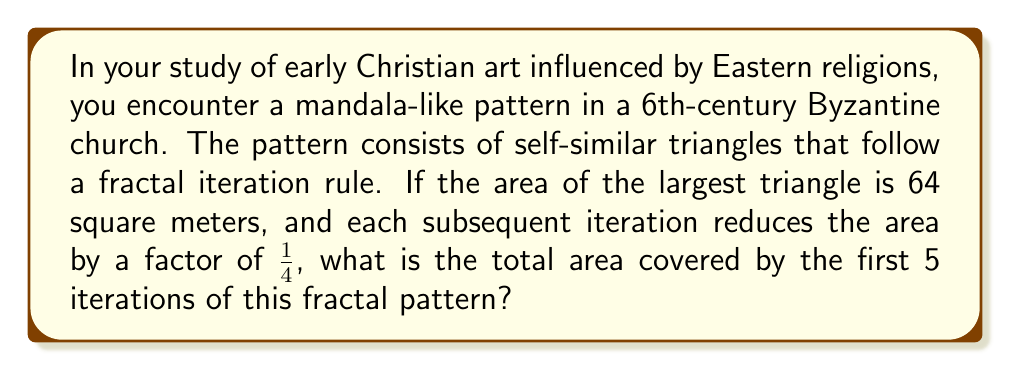Help me with this question. Let's approach this step-by-step:

1) First, let's define our series of areas:
   $A_1 = 64$ m² (given)
   $A_n = \frac{1}{4} A_{n-1}$ for $n > 1$

2) We can write out the first 5 terms:
   $A_1 = 64$ m²
   $A_2 = 64 \cdot \frac{1}{4} = 16$ m²
   $A_3 = 16 \cdot \frac{1}{4} = 4$ m²
   $A_4 = 4 \cdot \frac{1}{4} = 1$ m²
   $A_5 = 1 \cdot \frac{1}{4} = 0.25$ m²

3) The total area is the sum of these 5 terms:
   $A_{total} = A_1 + A_2 + A_3 + A_4 + A_5$

4) We can also express this as a geometric series:
   $A_{total} = 64 + 64(\frac{1}{4}) + 64(\frac{1}{4})^2 + 64(\frac{1}{4})^3 + 64(\frac{1}{4})^4$

5) This is a geometric series with first term $a = 64$ and common ratio $r = \frac{1}{4}$

6) The sum of a geometric series is given by the formula:
   $S_n = \frac{a(1-r^n)}{1-r}$, where $n = 5$ in this case

7) Plugging in our values:
   $A_{total} = \frac{64(1-(\frac{1}{4})^5)}{1-\frac{1}{4}} = \frac{64(1-\frac{1}{1024})}{3/4}$

8) Simplifying:
   $A_{total} = \frac{64(1023/1024)}{3/4} = \frac{64 \cdot 1023}{768} = 85.25$ m²
Answer: 85.25 m² 